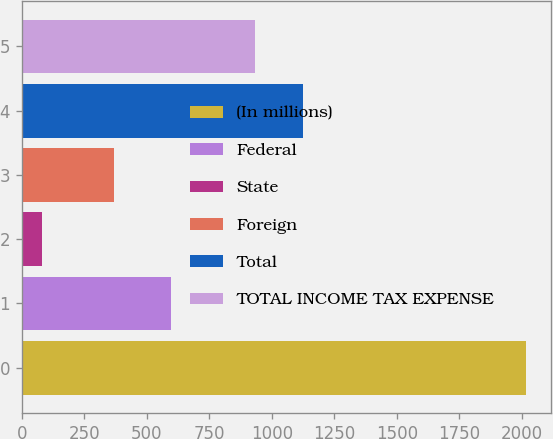Convert chart. <chart><loc_0><loc_0><loc_500><loc_500><bar_chart><fcel>(In millions)<fcel>Federal<fcel>State<fcel>Foreign<fcel>Total<fcel>TOTAL INCOME TAX EXPENSE<nl><fcel>2015<fcel>596<fcel>80<fcel>369<fcel>1125.5<fcel>932<nl></chart> 